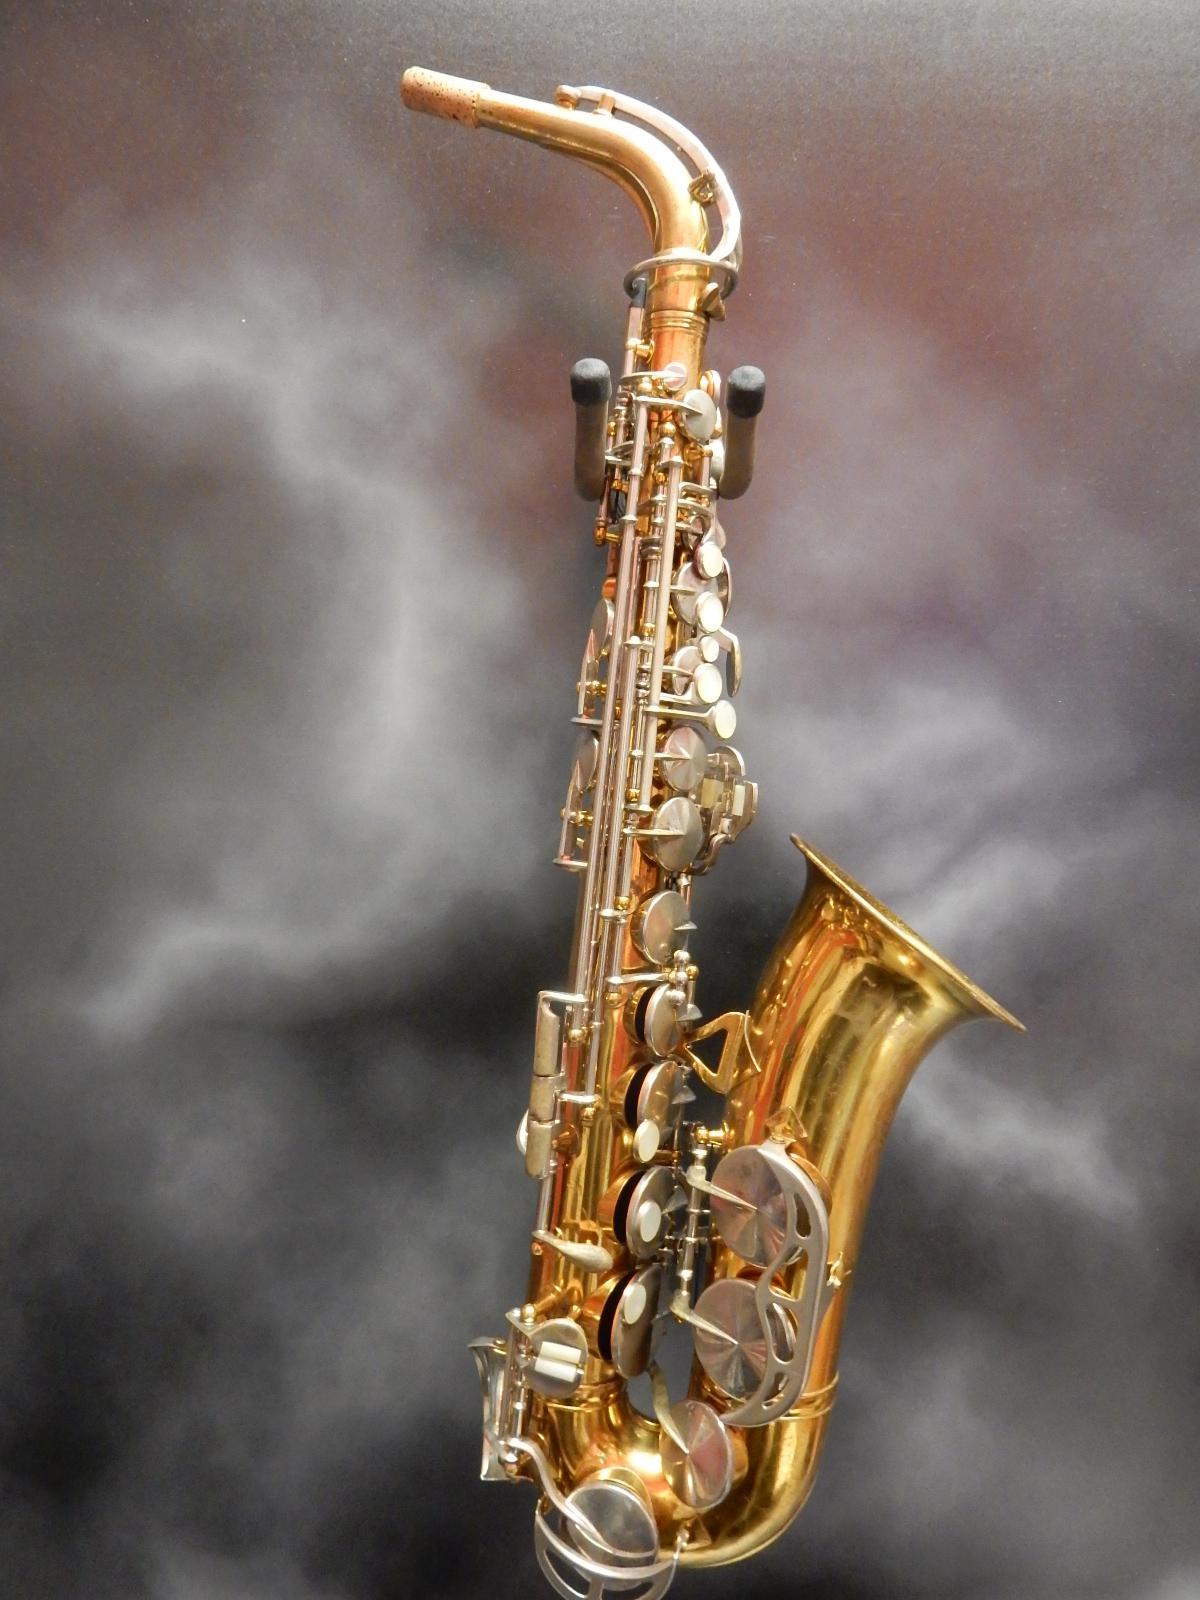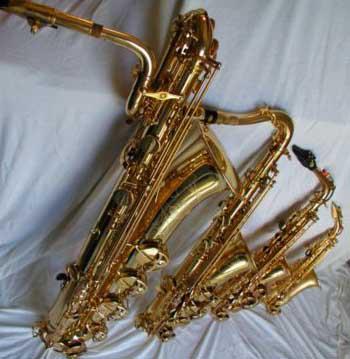The first image is the image on the left, the second image is the image on the right. Assess this claim about the two images: "All the sax's are facing the same direction.". Correct or not? Answer yes or no. Yes. The first image is the image on the left, the second image is the image on the right. Analyze the images presented: Is the assertion "One image shows the right-turned engraved bell of saxophone, and the other image shows one saxophone with mouthpiece intact." valid? Answer yes or no. No. 